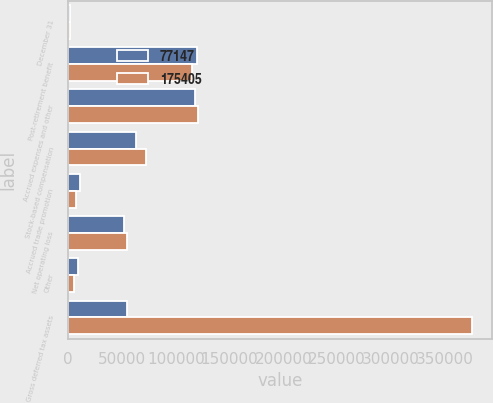<chart> <loc_0><loc_0><loc_500><loc_500><stacked_bar_chart><ecel><fcel>December 31<fcel>Post-retirement benefit<fcel>Accrued expenses and other<fcel>Stock-based compensation<fcel>Accrued trade promotion<fcel>Net operating loss<fcel>Other<fcel>Gross deferred tax assets<nl><fcel>77147<fcel>2011<fcel>120174<fcel>117939<fcel>62666<fcel>11209<fcel>51948<fcel>9016<fcel>54649<nl><fcel>175405<fcel>2010<fcel>115068<fcel>120258<fcel>72498<fcel>6902<fcel>54649<fcel>5598<fcel>374973<nl></chart> 